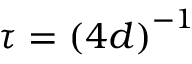Convert formula to latex. <formula><loc_0><loc_0><loc_500><loc_500>\tau = \left ( 4 d \right ) ^ { - 1 }</formula> 